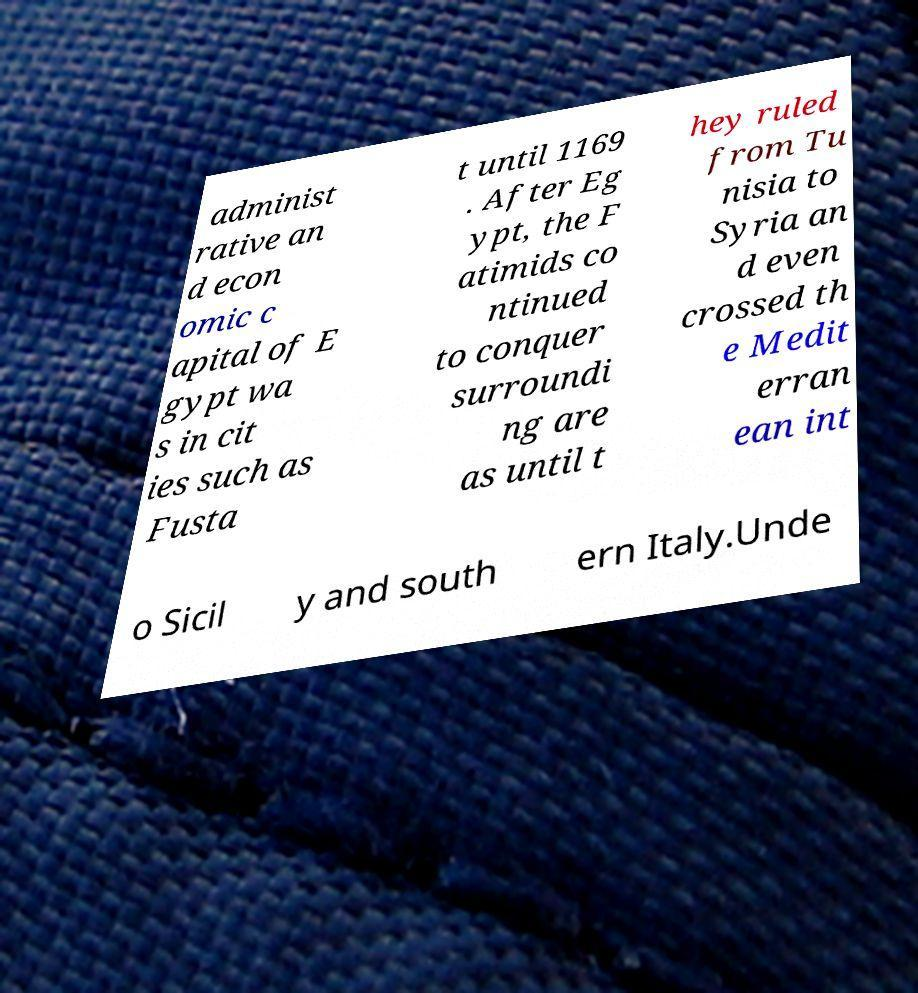Could you assist in decoding the text presented in this image and type it out clearly? administ rative an d econ omic c apital of E gypt wa s in cit ies such as Fusta t until 1169 . After Eg ypt, the F atimids co ntinued to conquer surroundi ng are as until t hey ruled from Tu nisia to Syria an d even crossed th e Medit erran ean int o Sicil y and south ern Italy.Unde 